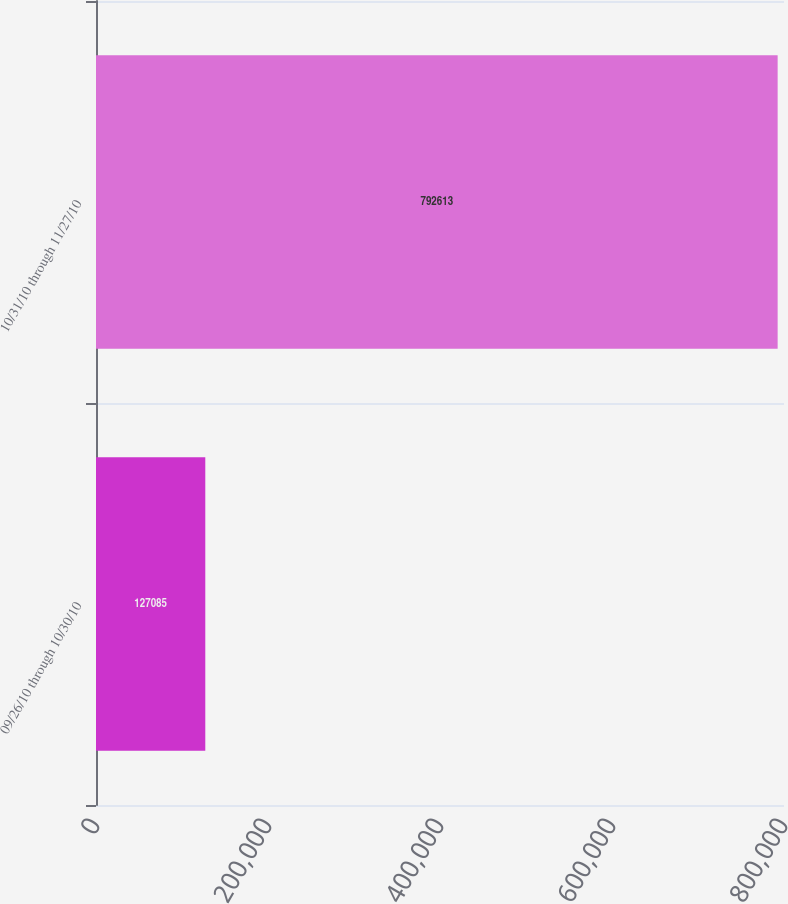Convert chart to OTSL. <chart><loc_0><loc_0><loc_500><loc_500><bar_chart><fcel>09/26/10 through 10/30/10<fcel>10/31/10 through 11/27/10<nl><fcel>127085<fcel>792613<nl></chart> 